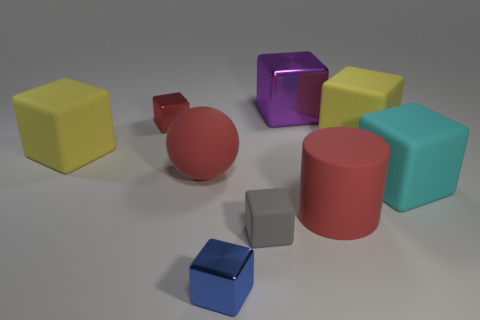Subtract 3 cubes. How many cubes are left? 4 Subtract all red blocks. How many blocks are left? 6 Subtract all yellow blocks. How many blocks are left? 5 Subtract all brown blocks. Subtract all cyan spheres. How many blocks are left? 7 Add 1 red matte things. How many objects exist? 10 Subtract all balls. How many objects are left? 8 Subtract 0 cyan balls. How many objects are left? 9 Subtract all purple metallic cubes. Subtract all small red metallic blocks. How many objects are left? 7 Add 3 large things. How many large things are left? 9 Add 7 tiny red metallic objects. How many tiny red metallic objects exist? 8 